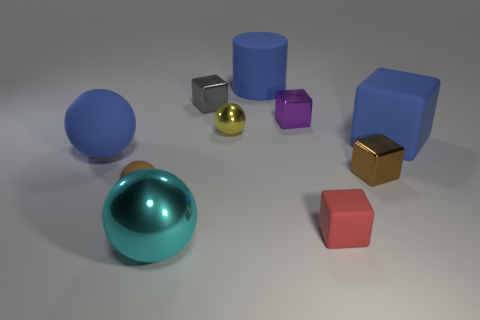There is a tiny metallic cube in front of the small sphere behind the brown object that is to the left of the large metal sphere; what is its color?
Ensure brevity in your answer.  Brown. Is the material of the brown thing to the left of the tiny purple cube the same as the big blue object on the left side of the blue cylinder?
Ensure brevity in your answer.  Yes. What shape is the blue rubber object that is to the left of the gray shiny cube?
Give a very brief answer. Sphere. How many things are brown metal cubes or rubber things that are on the right side of the small yellow thing?
Offer a terse response. 4. Is the material of the small gray object the same as the red block?
Provide a succinct answer. No. Is the number of tiny brown things behind the yellow object the same as the number of large metal spheres that are on the right side of the cyan shiny thing?
Give a very brief answer. Yes. There is a brown block; what number of tiny things are in front of it?
Your answer should be very brief. 2. What number of objects are either red rubber cubes or tiny purple metallic blocks?
Your answer should be very brief. 2. What number of other balls are the same size as the yellow sphere?
Offer a terse response. 1. The big rubber object that is to the left of the small metal thing on the left side of the tiny yellow sphere is what shape?
Provide a succinct answer. Sphere. 